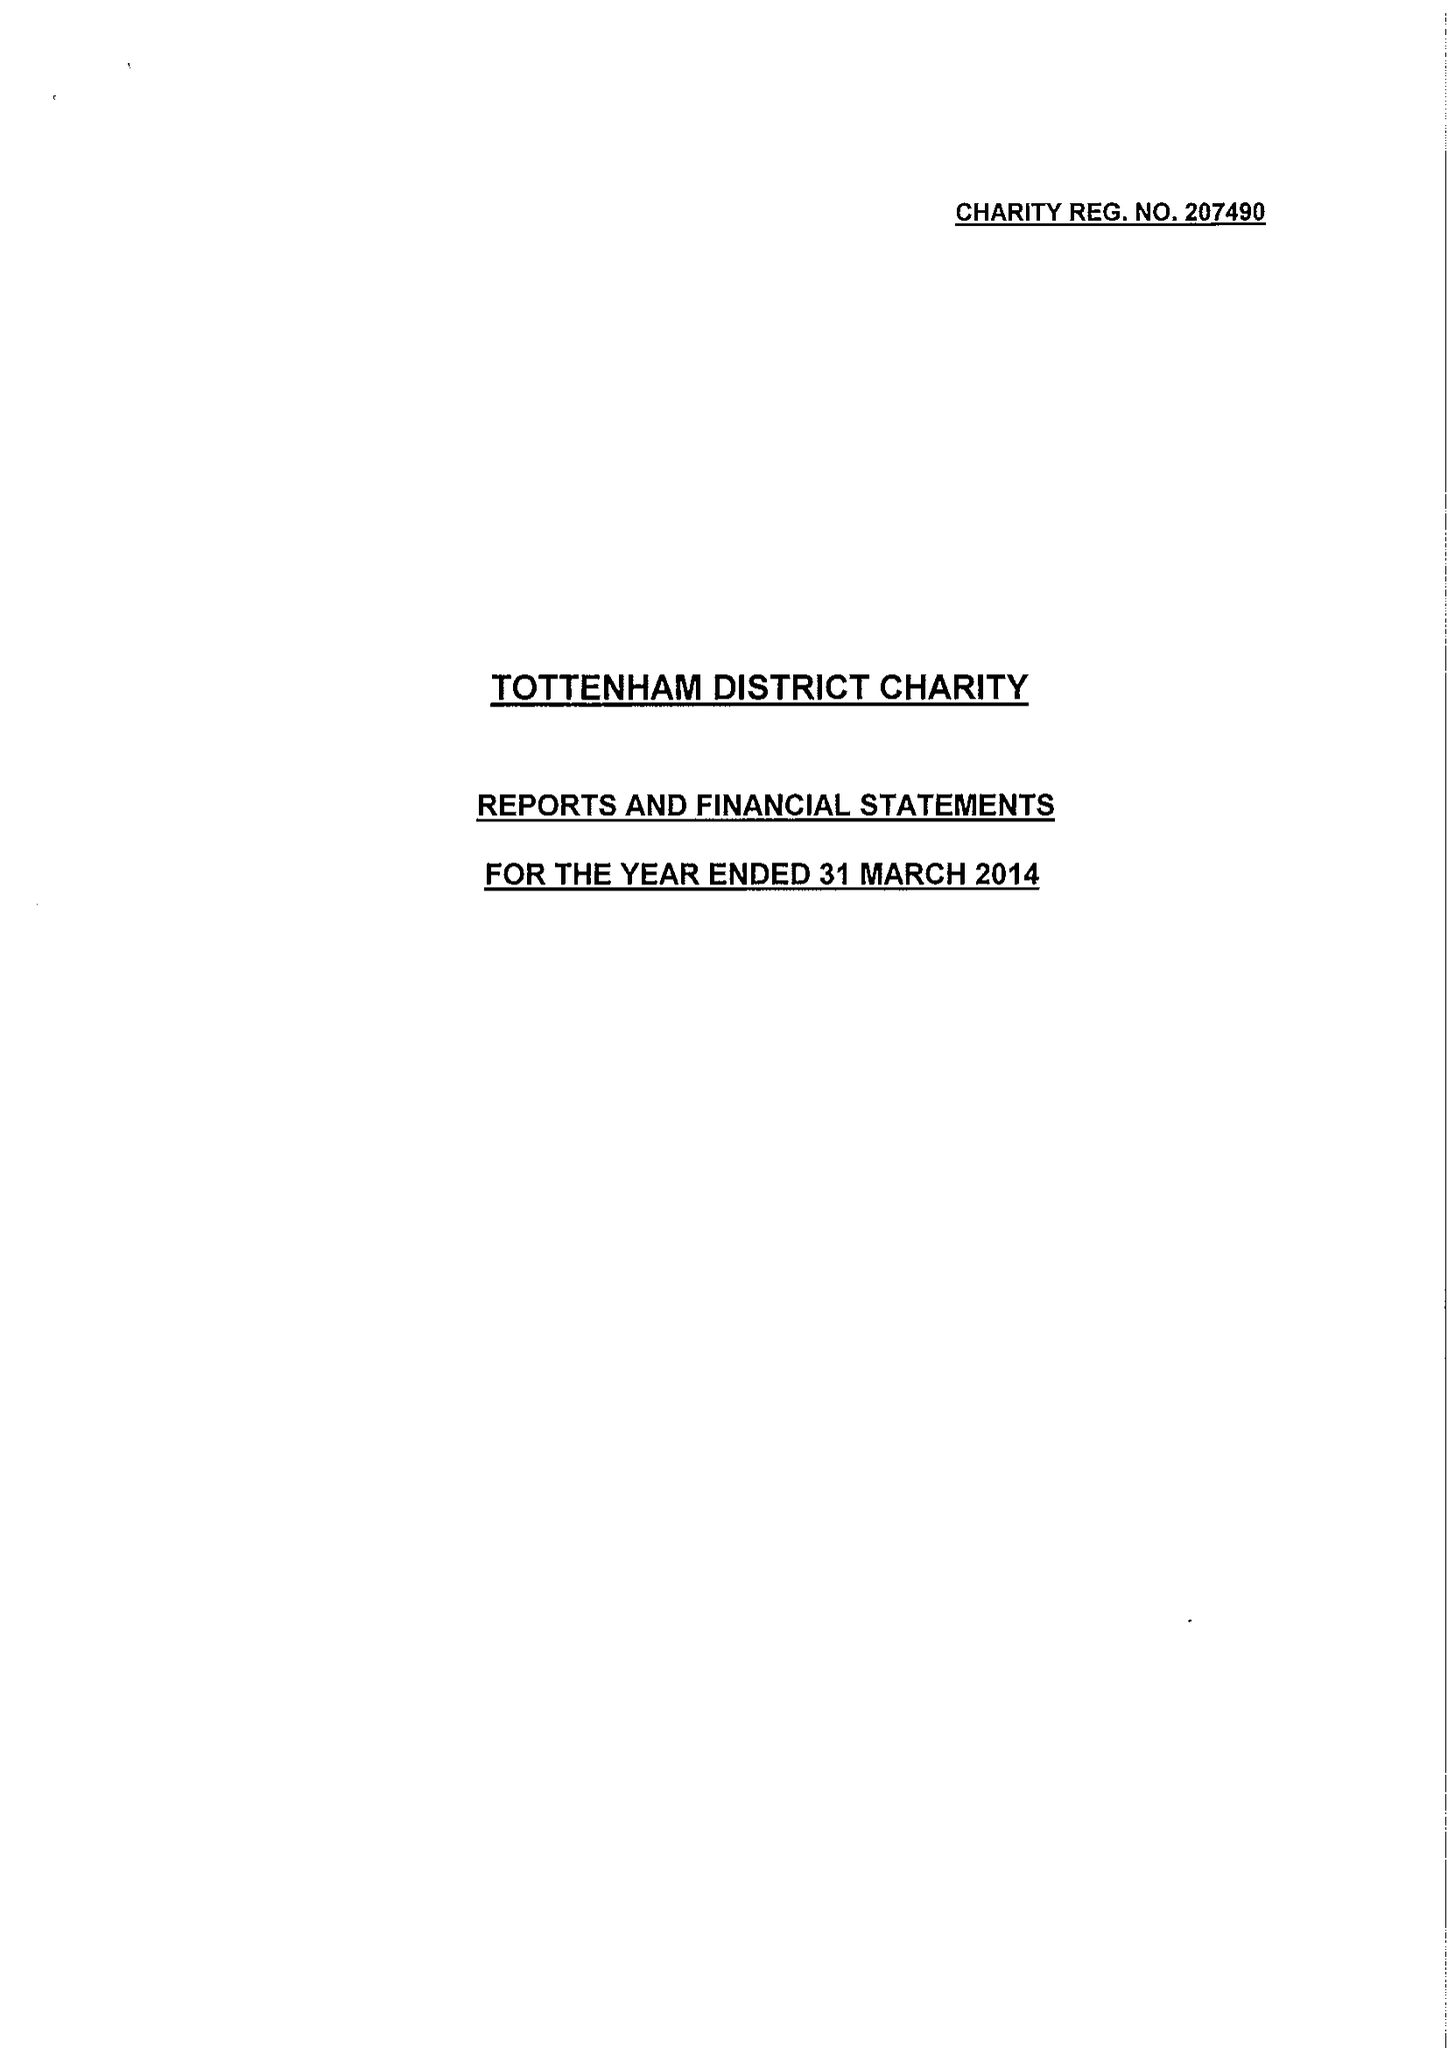What is the value for the address__postcode?
Answer the question using a single word or phrase. N22 8HQ 